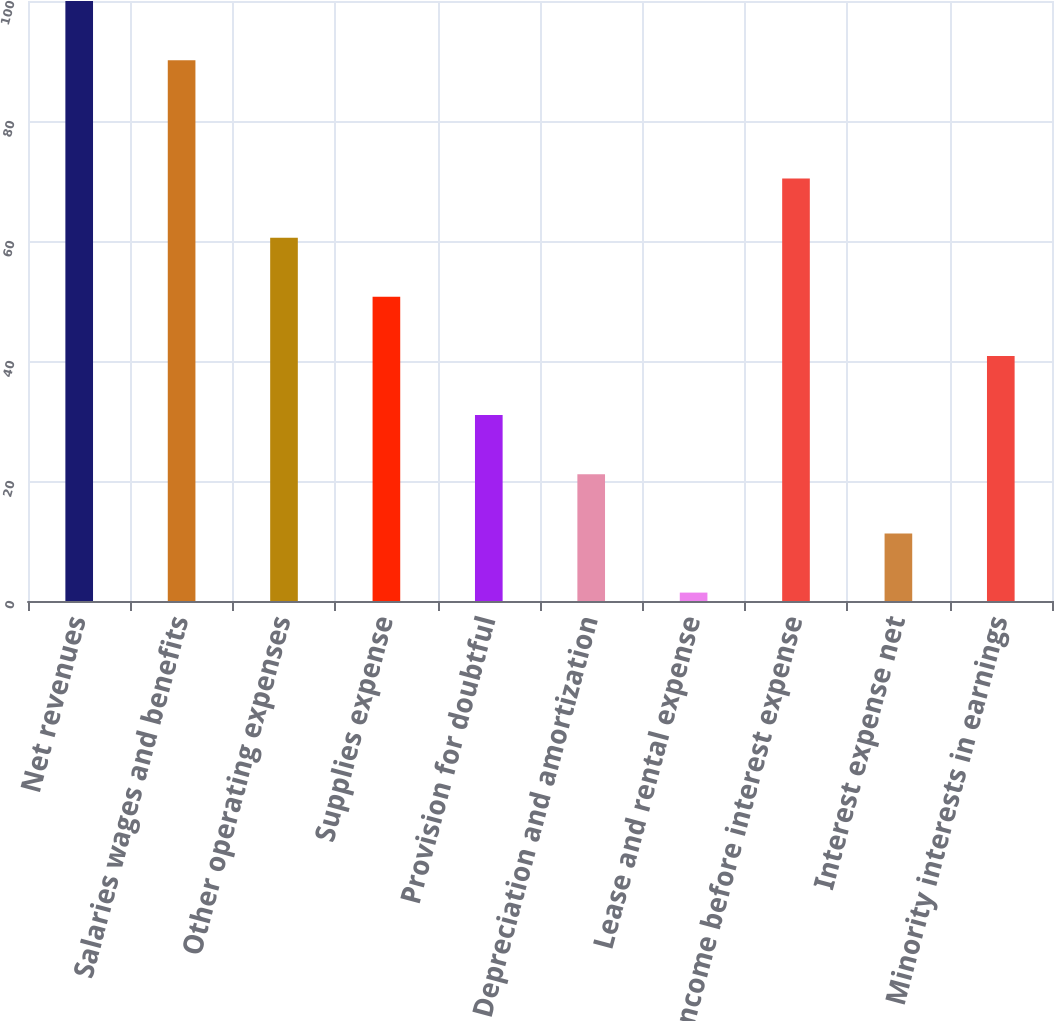Convert chart. <chart><loc_0><loc_0><loc_500><loc_500><bar_chart><fcel>Net revenues<fcel>Salaries wages and benefits<fcel>Other operating expenses<fcel>Supplies expense<fcel>Provision for doubtful<fcel>Depreciation and amortization<fcel>Lease and rental expense<fcel>Income before interest expense<fcel>Interest expense net<fcel>Minority interests in earnings<nl><fcel>100<fcel>90.14<fcel>60.56<fcel>50.7<fcel>30.98<fcel>21.12<fcel>1.4<fcel>70.42<fcel>11.26<fcel>40.84<nl></chart> 